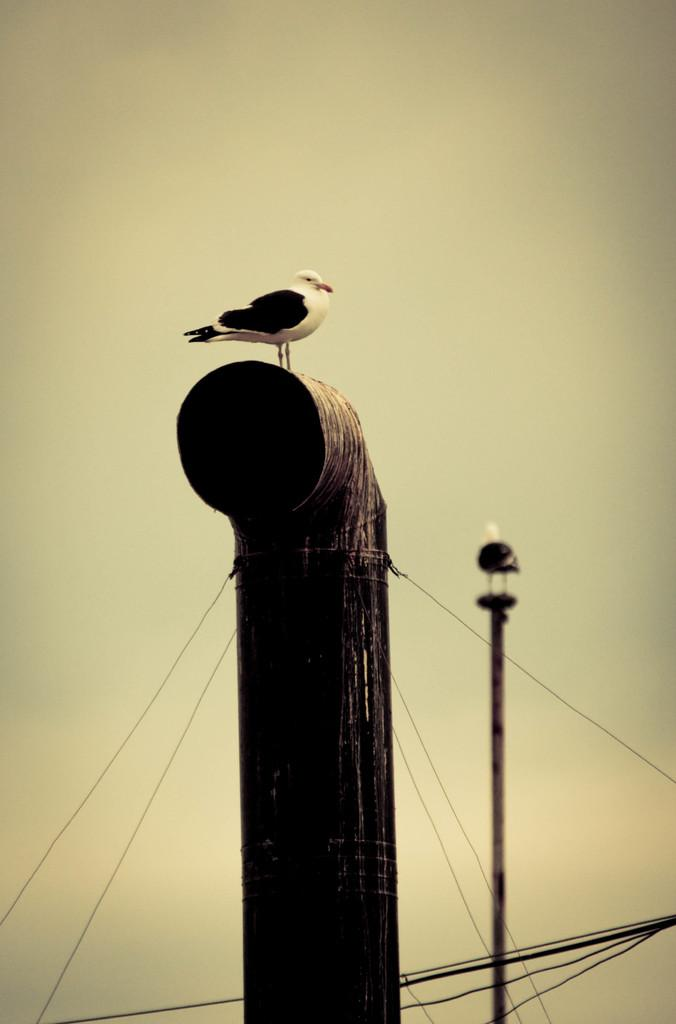What animals can be seen in the foreground of the image? There are two birds in the foreground of the image. What are the birds perched on? The birds are on poles. What else can be seen in the image besides the birds? There are cables visible in the image. What is visible in the background of the image? The sky is visible in the image. What type of milk is being poured into the bowl in the image? There is no bowl or milk present in the image; it features two birds on poles with cables and the sky visible in the background. 